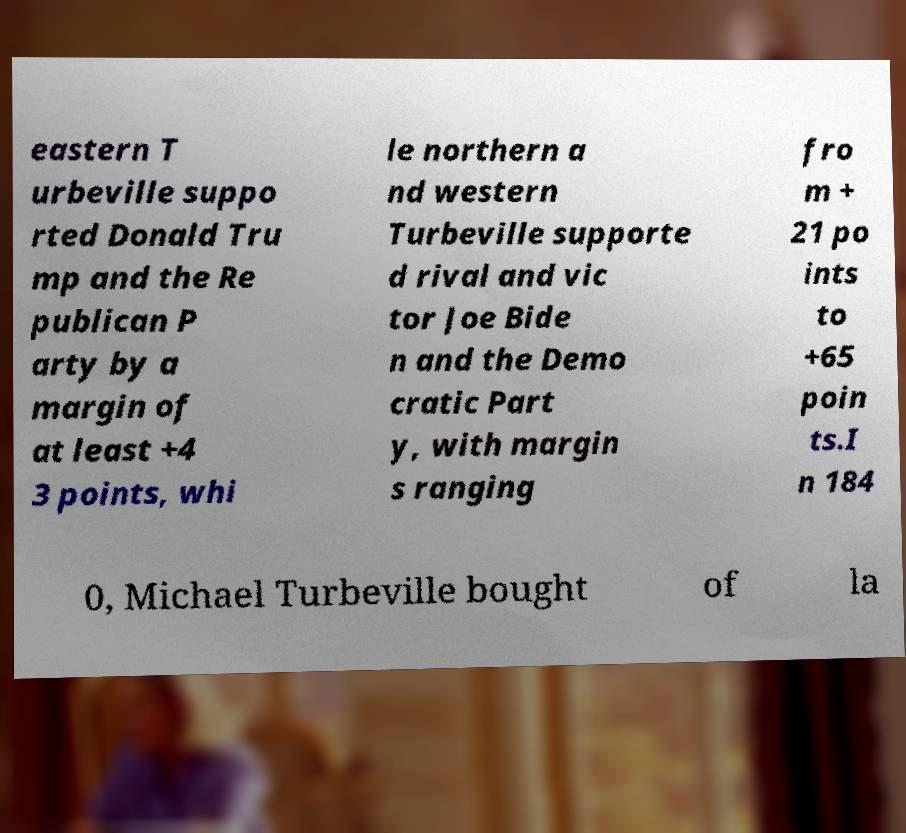What messages or text are displayed in this image? I need them in a readable, typed format. eastern T urbeville suppo rted Donald Tru mp and the Re publican P arty by a margin of at least +4 3 points, whi le northern a nd western Turbeville supporte d rival and vic tor Joe Bide n and the Demo cratic Part y, with margin s ranging fro m + 21 po ints to +65 poin ts.I n 184 0, Michael Turbeville bought of la 